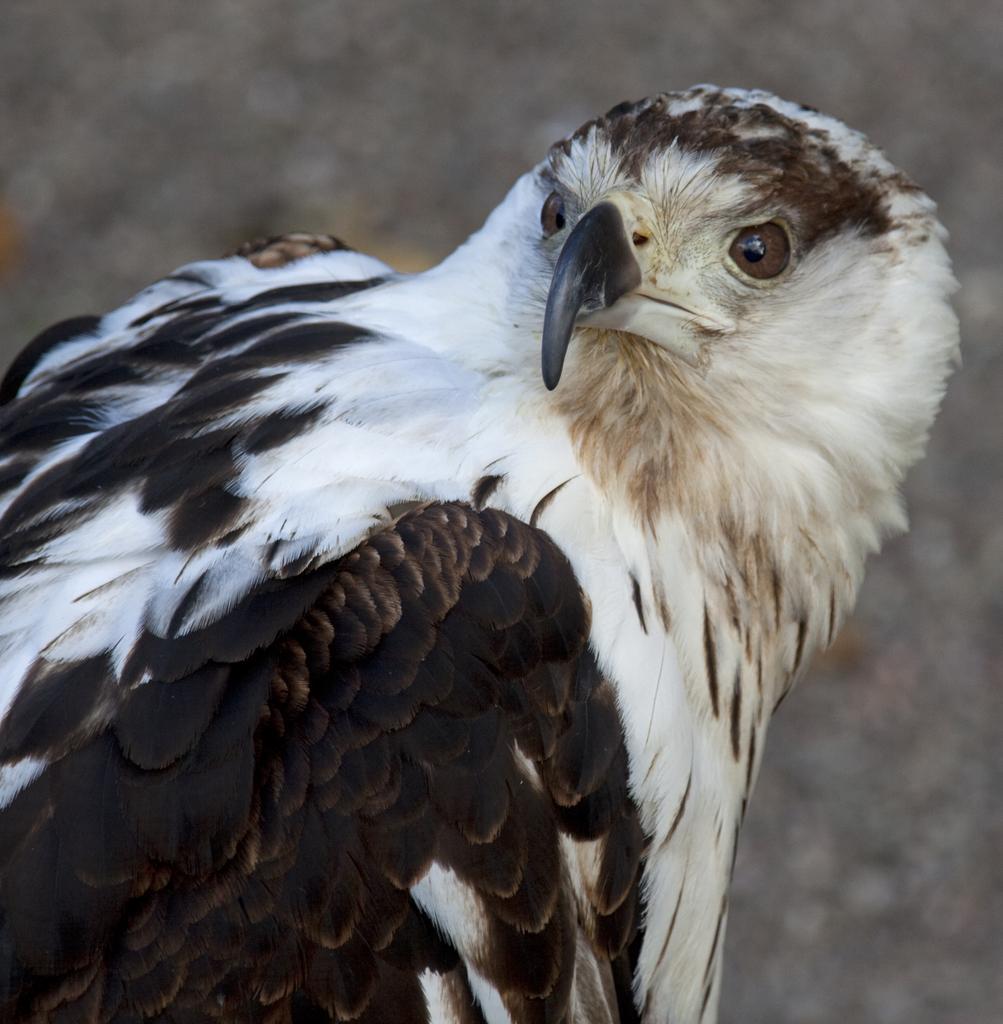Can you describe this image briefly? In this image in the foreground there is one bird, and in the background there are some trees. 